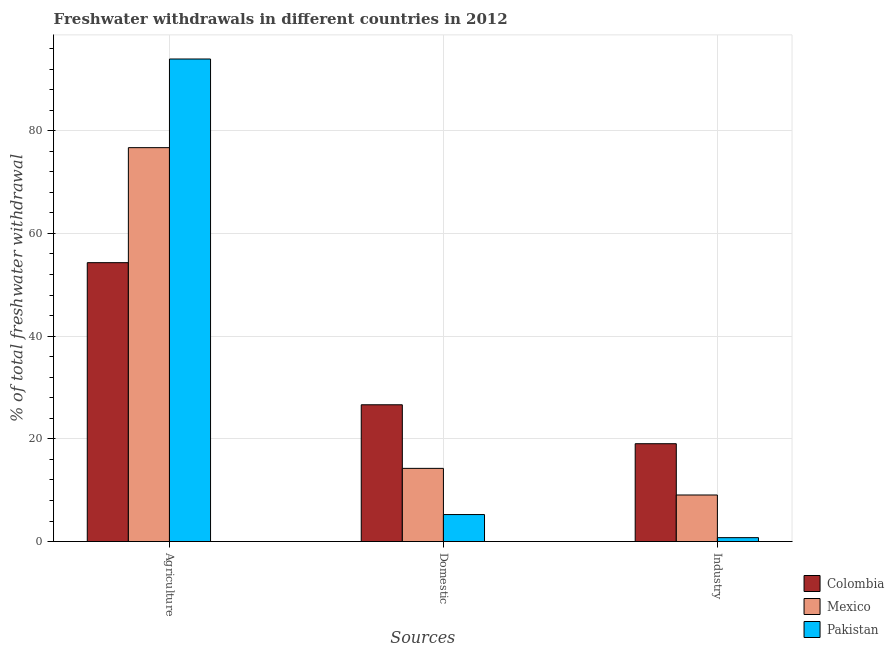Are the number of bars per tick equal to the number of legend labels?
Offer a very short reply. Yes. What is the label of the 2nd group of bars from the left?
Offer a terse response. Domestic. What is the percentage of freshwater withdrawal for domestic purposes in Colombia?
Provide a succinct answer. 26.63. Across all countries, what is the maximum percentage of freshwater withdrawal for agriculture?
Make the answer very short. 93.95. Across all countries, what is the minimum percentage of freshwater withdrawal for domestic purposes?
Make the answer very short. 5.26. In which country was the percentage of freshwater withdrawal for domestic purposes maximum?
Your response must be concise. Colombia. In which country was the percentage of freshwater withdrawal for industry minimum?
Offer a very short reply. Pakistan. What is the total percentage of freshwater withdrawal for agriculture in the graph?
Your answer should be very brief. 224.94. What is the difference between the percentage of freshwater withdrawal for industry in Pakistan and that in Mexico?
Keep it short and to the point. -8.3. What is the difference between the percentage of freshwater withdrawal for domestic purposes in Colombia and the percentage of freshwater withdrawal for agriculture in Mexico?
Your response must be concise. -50.06. What is the average percentage of freshwater withdrawal for industry per country?
Keep it short and to the point. 9.63. What is the difference between the percentage of freshwater withdrawal for domestic purposes and percentage of freshwater withdrawal for agriculture in Pakistan?
Keep it short and to the point. -88.69. What is the ratio of the percentage of freshwater withdrawal for domestic purposes in Colombia to that in Pakistan?
Provide a short and direct response. 5.06. Is the percentage of freshwater withdrawal for agriculture in Colombia less than that in Mexico?
Give a very brief answer. Yes. Is the difference between the percentage of freshwater withdrawal for industry in Pakistan and Mexico greater than the difference between the percentage of freshwater withdrawal for domestic purposes in Pakistan and Mexico?
Make the answer very short. Yes. What is the difference between the highest and the second highest percentage of freshwater withdrawal for industry?
Offer a very short reply. 9.98. What is the difference between the highest and the lowest percentage of freshwater withdrawal for domestic purposes?
Provide a succinct answer. 21.37. Is the sum of the percentage of freshwater withdrawal for industry in Colombia and Mexico greater than the maximum percentage of freshwater withdrawal for domestic purposes across all countries?
Provide a short and direct response. Yes. What does the 2nd bar from the left in Domestic represents?
Give a very brief answer. Mexico. How many bars are there?
Provide a succinct answer. 9. How many countries are there in the graph?
Give a very brief answer. 3. What is the difference between two consecutive major ticks on the Y-axis?
Ensure brevity in your answer.  20. Are the values on the major ticks of Y-axis written in scientific E-notation?
Offer a terse response. No. Does the graph contain grids?
Ensure brevity in your answer.  Yes. How many legend labels are there?
Your answer should be compact. 3. What is the title of the graph?
Give a very brief answer. Freshwater withdrawals in different countries in 2012. What is the label or title of the X-axis?
Ensure brevity in your answer.  Sources. What is the label or title of the Y-axis?
Give a very brief answer. % of total freshwater withdrawal. What is the % of total freshwater withdrawal in Colombia in Agriculture?
Give a very brief answer. 54.3. What is the % of total freshwater withdrawal of Mexico in Agriculture?
Your answer should be very brief. 76.69. What is the % of total freshwater withdrawal in Pakistan in Agriculture?
Offer a very short reply. 93.95. What is the % of total freshwater withdrawal in Colombia in Domestic?
Your answer should be compact. 26.63. What is the % of total freshwater withdrawal of Mexico in Domestic?
Your answer should be compact. 14.25. What is the % of total freshwater withdrawal of Pakistan in Domestic?
Ensure brevity in your answer.  5.26. What is the % of total freshwater withdrawal in Colombia in Industry?
Your answer should be very brief. 19.05. What is the % of total freshwater withdrawal in Mexico in Industry?
Give a very brief answer. 9.07. What is the % of total freshwater withdrawal of Pakistan in Industry?
Offer a very short reply. 0.76. Across all Sources, what is the maximum % of total freshwater withdrawal in Colombia?
Ensure brevity in your answer.  54.3. Across all Sources, what is the maximum % of total freshwater withdrawal of Mexico?
Provide a short and direct response. 76.69. Across all Sources, what is the maximum % of total freshwater withdrawal of Pakistan?
Your answer should be compact. 93.95. Across all Sources, what is the minimum % of total freshwater withdrawal of Colombia?
Give a very brief answer. 19.05. Across all Sources, what is the minimum % of total freshwater withdrawal of Mexico?
Keep it short and to the point. 9.07. Across all Sources, what is the minimum % of total freshwater withdrawal in Pakistan?
Offer a terse response. 0.76. What is the total % of total freshwater withdrawal in Colombia in the graph?
Ensure brevity in your answer.  99.98. What is the total % of total freshwater withdrawal of Mexico in the graph?
Give a very brief answer. 100.01. What is the total % of total freshwater withdrawal of Pakistan in the graph?
Provide a short and direct response. 99.97. What is the difference between the % of total freshwater withdrawal of Colombia in Agriculture and that in Domestic?
Provide a succinct answer. 27.67. What is the difference between the % of total freshwater withdrawal of Mexico in Agriculture and that in Domestic?
Make the answer very short. 62.44. What is the difference between the % of total freshwater withdrawal in Pakistan in Agriculture and that in Domestic?
Keep it short and to the point. 88.69. What is the difference between the % of total freshwater withdrawal of Colombia in Agriculture and that in Industry?
Your answer should be very brief. 35.25. What is the difference between the % of total freshwater withdrawal of Mexico in Agriculture and that in Industry?
Keep it short and to the point. 67.62. What is the difference between the % of total freshwater withdrawal of Pakistan in Agriculture and that in Industry?
Give a very brief answer. 93.19. What is the difference between the % of total freshwater withdrawal in Colombia in Domestic and that in Industry?
Provide a succinct answer. 7.58. What is the difference between the % of total freshwater withdrawal in Mexico in Domestic and that in Industry?
Make the answer very short. 5.18. What is the difference between the % of total freshwater withdrawal of Pakistan in Domestic and that in Industry?
Offer a terse response. 4.5. What is the difference between the % of total freshwater withdrawal of Colombia in Agriculture and the % of total freshwater withdrawal of Mexico in Domestic?
Your answer should be very brief. 40.05. What is the difference between the % of total freshwater withdrawal of Colombia in Agriculture and the % of total freshwater withdrawal of Pakistan in Domestic?
Your answer should be compact. 49.04. What is the difference between the % of total freshwater withdrawal of Mexico in Agriculture and the % of total freshwater withdrawal of Pakistan in Domestic?
Provide a short and direct response. 71.43. What is the difference between the % of total freshwater withdrawal in Colombia in Agriculture and the % of total freshwater withdrawal in Mexico in Industry?
Keep it short and to the point. 45.23. What is the difference between the % of total freshwater withdrawal in Colombia in Agriculture and the % of total freshwater withdrawal in Pakistan in Industry?
Ensure brevity in your answer.  53.54. What is the difference between the % of total freshwater withdrawal of Mexico in Agriculture and the % of total freshwater withdrawal of Pakistan in Industry?
Ensure brevity in your answer.  75.93. What is the difference between the % of total freshwater withdrawal in Colombia in Domestic and the % of total freshwater withdrawal in Mexico in Industry?
Provide a short and direct response. 17.56. What is the difference between the % of total freshwater withdrawal in Colombia in Domestic and the % of total freshwater withdrawal in Pakistan in Industry?
Ensure brevity in your answer.  25.87. What is the difference between the % of total freshwater withdrawal of Mexico in Domestic and the % of total freshwater withdrawal of Pakistan in Industry?
Your answer should be compact. 13.49. What is the average % of total freshwater withdrawal in Colombia per Sources?
Ensure brevity in your answer.  33.33. What is the average % of total freshwater withdrawal of Mexico per Sources?
Provide a succinct answer. 33.34. What is the average % of total freshwater withdrawal in Pakistan per Sources?
Your answer should be compact. 33.32. What is the difference between the % of total freshwater withdrawal in Colombia and % of total freshwater withdrawal in Mexico in Agriculture?
Provide a short and direct response. -22.39. What is the difference between the % of total freshwater withdrawal in Colombia and % of total freshwater withdrawal in Pakistan in Agriculture?
Provide a short and direct response. -39.65. What is the difference between the % of total freshwater withdrawal of Mexico and % of total freshwater withdrawal of Pakistan in Agriculture?
Give a very brief answer. -17.26. What is the difference between the % of total freshwater withdrawal of Colombia and % of total freshwater withdrawal of Mexico in Domestic?
Your answer should be very brief. 12.38. What is the difference between the % of total freshwater withdrawal of Colombia and % of total freshwater withdrawal of Pakistan in Domestic?
Your answer should be compact. 21.37. What is the difference between the % of total freshwater withdrawal of Mexico and % of total freshwater withdrawal of Pakistan in Domestic?
Make the answer very short. 8.99. What is the difference between the % of total freshwater withdrawal of Colombia and % of total freshwater withdrawal of Mexico in Industry?
Your response must be concise. 9.98. What is the difference between the % of total freshwater withdrawal in Colombia and % of total freshwater withdrawal in Pakistan in Industry?
Keep it short and to the point. 18.29. What is the difference between the % of total freshwater withdrawal in Mexico and % of total freshwater withdrawal in Pakistan in Industry?
Ensure brevity in your answer.  8.3. What is the ratio of the % of total freshwater withdrawal in Colombia in Agriculture to that in Domestic?
Your response must be concise. 2.04. What is the ratio of the % of total freshwater withdrawal in Mexico in Agriculture to that in Domestic?
Offer a very short reply. 5.38. What is the ratio of the % of total freshwater withdrawal of Pakistan in Agriculture to that in Domestic?
Offer a terse response. 17.86. What is the ratio of the % of total freshwater withdrawal in Colombia in Agriculture to that in Industry?
Provide a short and direct response. 2.85. What is the ratio of the % of total freshwater withdrawal of Mexico in Agriculture to that in Industry?
Your answer should be very brief. 8.46. What is the ratio of the % of total freshwater withdrawal in Pakistan in Agriculture to that in Industry?
Offer a very short reply. 123.15. What is the ratio of the % of total freshwater withdrawal of Colombia in Domestic to that in Industry?
Make the answer very short. 1.4. What is the ratio of the % of total freshwater withdrawal in Mexico in Domestic to that in Industry?
Your response must be concise. 1.57. What is the ratio of the % of total freshwater withdrawal of Pakistan in Domestic to that in Industry?
Ensure brevity in your answer.  6.89. What is the difference between the highest and the second highest % of total freshwater withdrawal in Colombia?
Your answer should be very brief. 27.67. What is the difference between the highest and the second highest % of total freshwater withdrawal in Mexico?
Provide a succinct answer. 62.44. What is the difference between the highest and the second highest % of total freshwater withdrawal in Pakistan?
Offer a terse response. 88.69. What is the difference between the highest and the lowest % of total freshwater withdrawal in Colombia?
Your response must be concise. 35.25. What is the difference between the highest and the lowest % of total freshwater withdrawal of Mexico?
Give a very brief answer. 67.62. What is the difference between the highest and the lowest % of total freshwater withdrawal in Pakistan?
Provide a short and direct response. 93.19. 